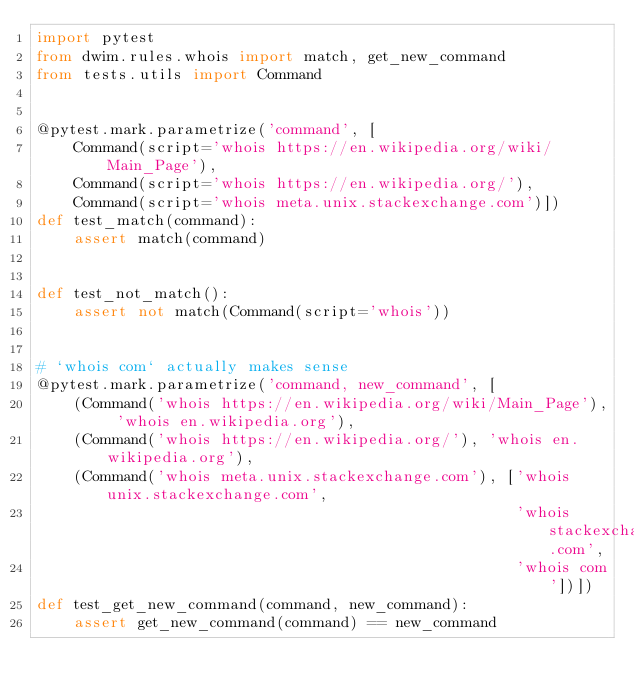<code> <loc_0><loc_0><loc_500><loc_500><_Python_>import pytest
from dwim.rules.whois import match, get_new_command
from tests.utils import Command


@pytest.mark.parametrize('command', [
    Command(script='whois https://en.wikipedia.org/wiki/Main_Page'),
    Command(script='whois https://en.wikipedia.org/'),
    Command(script='whois meta.unix.stackexchange.com')])
def test_match(command):
    assert match(command)


def test_not_match():
    assert not match(Command(script='whois'))


# `whois com` actually makes sense
@pytest.mark.parametrize('command, new_command', [
    (Command('whois https://en.wikipedia.org/wiki/Main_Page'), 'whois en.wikipedia.org'),
    (Command('whois https://en.wikipedia.org/'), 'whois en.wikipedia.org'),
    (Command('whois meta.unix.stackexchange.com'), ['whois unix.stackexchange.com',
                                                    'whois stackexchange.com',
                                                    'whois com'])])
def test_get_new_command(command, new_command):
    assert get_new_command(command) == new_command
</code> 